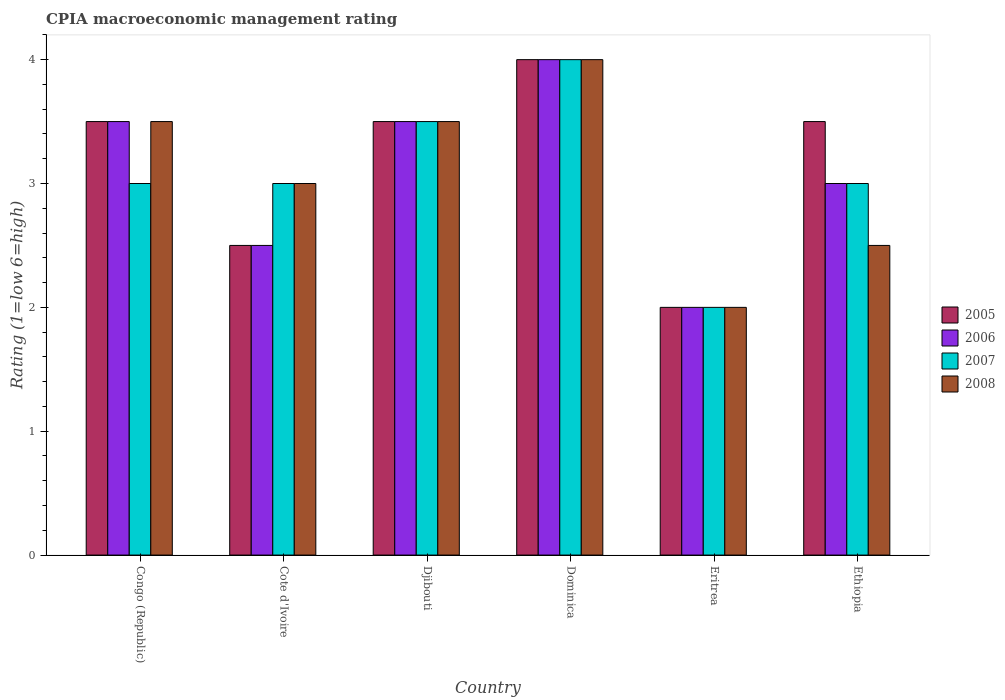How many different coloured bars are there?
Make the answer very short. 4. Are the number of bars per tick equal to the number of legend labels?
Your answer should be very brief. Yes. Are the number of bars on each tick of the X-axis equal?
Provide a short and direct response. Yes. How many bars are there on the 2nd tick from the right?
Provide a succinct answer. 4. What is the label of the 3rd group of bars from the left?
Provide a succinct answer. Djibouti. In how many cases, is the number of bars for a given country not equal to the number of legend labels?
Provide a succinct answer. 0. What is the CPIA rating in 2006 in Ethiopia?
Offer a very short reply. 3. In which country was the CPIA rating in 2006 maximum?
Give a very brief answer. Dominica. In which country was the CPIA rating in 2006 minimum?
Keep it short and to the point. Eritrea. What is the difference between the CPIA rating in 2005 in Cote d'Ivoire and the CPIA rating in 2006 in Djibouti?
Make the answer very short. -1. What is the average CPIA rating in 2007 per country?
Make the answer very short. 3.08. In how many countries, is the CPIA rating in 2005 greater than 0.6000000000000001?
Your answer should be compact. 6. What is the ratio of the CPIA rating in 2005 in Cote d'Ivoire to that in Djibouti?
Provide a succinct answer. 0.71. Is the difference between the CPIA rating in 2007 in Djibouti and Ethiopia greater than the difference between the CPIA rating in 2006 in Djibouti and Ethiopia?
Make the answer very short. No. What is the difference between the highest and the second highest CPIA rating in 2006?
Your answer should be very brief. -0.5. What is the difference between the highest and the lowest CPIA rating in 2006?
Offer a terse response. 2. Is the sum of the CPIA rating in 2006 in Djibouti and Dominica greater than the maximum CPIA rating in 2008 across all countries?
Provide a short and direct response. Yes. What does the 4th bar from the right in Djibouti represents?
Your response must be concise. 2005. Is it the case that in every country, the sum of the CPIA rating in 2007 and CPIA rating in 2008 is greater than the CPIA rating in 2005?
Give a very brief answer. Yes. How many bars are there?
Give a very brief answer. 24. How many countries are there in the graph?
Your answer should be very brief. 6. Does the graph contain grids?
Ensure brevity in your answer.  No. Where does the legend appear in the graph?
Keep it short and to the point. Center right. How many legend labels are there?
Your response must be concise. 4. What is the title of the graph?
Your response must be concise. CPIA macroeconomic management rating. What is the Rating (1=low 6=high) of 2005 in Djibouti?
Provide a succinct answer. 3.5. What is the Rating (1=low 6=high) of 2005 in Dominica?
Your response must be concise. 4. What is the Rating (1=low 6=high) of 2007 in Eritrea?
Provide a succinct answer. 2. What is the Rating (1=low 6=high) of 2008 in Eritrea?
Offer a terse response. 2. What is the Rating (1=low 6=high) of 2006 in Ethiopia?
Make the answer very short. 3. What is the Rating (1=low 6=high) in 2007 in Ethiopia?
Offer a very short reply. 3. Across all countries, what is the maximum Rating (1=low 6=high) in 2007?
Offer a very short reply. 4. Across all countries, what is the maximum Rating (1=low 6=high) of 2008?
Ensure brevity in your answer.  4. Across all countries, what is the minimum Rating (1=low 6=high) of 2005?
Offer a very short reply. 2. What is the total Rating (1=low 6=high) of 2005 in the graph?
Provide a short and direct response. 19. What is the total Rating (1=low 6=high) in 2006 in the graph?
Offer a very short reply. 18.5. What is the difference between the Rating (1=low 6=high) in 2005 in Congo (Republic) and that in Cote d'Ivoire?
Give a very brief answer. 1. What is the difference between the Rating (1=low 6=high) of 2007 in Congo (Republic) and that in Cote d'Ivoire?
Your answer should be very brief. 0. What is the difference between the Rating (1=low 6=high) in 2005 in Congo (Republic) and that in Dominica?
Provide a short and direct response. -0.5. What is the difference between the Rating (1=low 6=high) of 2008 in Congo (Republic) and that in Dominica?
Your answer should be compact. -0.5. What is the difference between the Rating (1=low 6=high) of 2006 in Congo (Republic) and that in Eritrea?
Your answer should be compact. 1.5. What is the difference between the Rating (1=low 6=high) of 2007 in Congo (Republic) and that in Eritrea?
Give a very brief answer. 1. What is the difference between the Rating (1=low 6=high) in 2005 in Congo (Republic) and that in Ethiopia?
Ensure brevity in your answer.  0. What is the difference between the Rating (1=low 6=high) in 2006 in Congo (Republic) and that in Ethiopia?
Your response must be concise. 0.5. What is the difference between the Rating (1=low 6=high) of 2007 in Congo (Republic) and that in Ethiopia?
Your answer should be compact. 0. What is the difference between the Rating (1=low 6=high) of 2006 in Cote d'Ivoire and that in Djibouti?
Keep it short and to the point. -1. What is the difference between the Rating (1=low 6=high) of 2008 in Cote d'Ivoire and that in Djibouti?
Provide a short and direct response. -0.5. What is the difference between the Rating (1=low 6=high) of 2006 in Cote d'Ivoire and that in Dominica?
Your response must be concise. -1.5. What is the difference between the Rating (1=low 6=high) of 2008 in Cote d'Ivoire and that in Dominica?
Keep it short and to the point. -1. What is the difference between the Rating (1=low 6=high) of 2006 in Cote d'Ivoire and that in Eritrea?
Your answer should be compact. 0.5. What is the difference between the Rating (1=low 6=high) of 2007 in Cote d'Ivoire and that in Eritrea?
Your answer should be compact. 1. What is the difference between the Rating (1=low 6=high) in 2008 in Cote d'Ivoire and that in Eritrea?
Provide a succinct answer. 1. What is the difference between the Rating (1=low 6=high) of 2005 in Djibouti and that in Dominica?
Provide a short and direct response. -0.5. What is the difference between the Rating (1=low 6=high) in 2006 in Djibouti and that in Dominica?
Ensure brevity in your answer.  -0.5. What is the difference between the Rating (1=low 6=high) in 2005 in Djibouti and that in Eritrea?
Provide a short and direct response. 1.5. What is the difference between the Rating (1=low 6=high) in 2006 in Djibouti and that in Eritrea?
Your response must be concise. 1.5. What is the difference between the Rating (1=low 6=high) of 2005 in Djibouti and that in Ethiopia?
Give a very brief answer. 0. What is the difference between the Rating (1=low 6=high) of 2006 in Djibouti and that in Ethiopia?
Give a very brief answer. 0.5. What is the difference between the Rating (1=low 6=high) of 2006 in Dominica and that in Eritrea?
Provide a succinct answer. 2. What is the difference between the Rating (1=low 6=high) of 2008 in Dominica and that in Eritrea?
Your answer should be very brief. 2. What is the difference between the Rating (1=low 6=high) in 2005 in Dominica and that in Ethiopia?
Your response must be concise. 0.5. What is the difference between the Rating (1=low 6=high) in 2007 in Dominica and that in Ethiopia?
Keep it short and to the point. 1. What is the difference between the Rating (1=low 6=high) of 2008 in Dominica and that in Ethiopia?
Give a very brief answer. 1.5. What is the difference between the Rating (1=low 6=high) of 2005 in Eritrea and that in Ethiopia?
Provide a short and direct response. -1.5. What is the difference between the Rating (1=low 6=high) in 2007 in Eritrea and that in Ethiopia?
Offer a very short reply. -1. What is the difference between the Rating (1=low 6=high) of 2008 in Eritrea and that in Ethiopia?
Your response must be concise. -0.5. What is the difference between the Rating (1=low 6=high) in 2005 in Congo (Republic) and the Rating (1=low 6=high) in 2006 in Cote d'Ivoire?
Your answer should be very brief. 1. What is the difference between the Rating (1=low 6=high) in 2005 in Congo (Republic) and the Rating (1=low 6=high) in 2007 in Cote d'Ivoire?
Provide a succinct answer. 0.5. What is the difference between the Rating (1=low 6=high) in 2005 in Congo (Republic) and the Rating (1=low 6=high) in 2008 in Cote d'Ivoire?
Your answer should be very brief. 0.5. What is the difference between the Rating (1=low 6=high) of 2006 in Congo (Republic) and the Rating (1=low 6=high) of 2007 in Cote d'Ivoire?
Keep it short and to the point. 0.5. What is the difference between the Rating (1=low 6=high) in 2006 in Congo (Republic) and the Rating (1=low 6=high) in 2008 in Cote d'Ivoire?
Make the answer very short. 0.5. What is the difference between the Rating (1=low 6=high) in 2005 in Congo (Republic) and the Rating (1=low 6=high) in 2008 in Djibouti?
Offer a terse response. 0. What is the difference between the Rating (1=low 6=high) in 2005 in Congo (Republic) and the Rating (1=low 6=high) in 2008 in Dominica?
Offer a very short reply. -0.5. What is the difference between the Rating (1=low 6=high) of 2006 in Congo (Republic) and the Rating (1=low 6=high) of 2007 in Dominica?
Ensure brevity in your answer.  -0.5. What is the difference between the Rating (1=low 6=high) in 2007 in Congo (Republic) and the Rating (1=low 6=high) in 2008 in Dominica?
Keep it short and to the point. -1. What is the difference between the Rating (1=low 6=high) in 2005 in Congo (Republic) and the Rating (1=low 6=high) in 2007 in Eritrea?
Give a very brief answer. 1.5. What is the difference between the Rating (1=low 6=high) in 2005 in Congo (Republic) and the Rating (1=low 6=high) in 2008 in Eritrea?
Offer a very short reply. 1.5. What is the difference between the Rating (1=low 6=high) in 2006 in Congo (Republic) and the Rating (1=low 6=high) in 2007 in Eritrea?
Make the answer very short. 1.5. What is the difference between the Rating (1=low 6=high) of 2007 in Congo (Republic) and the Rating (1=low 6=high) of 2008 in Eritrea?
Provide a succinct answer. 1. What is the difference between the Rating (1=low 6=high) in 2005 in Congo (Republic) and the Rating (1=low 6=high) in 2008 in Ethiopia?
Offer a terse response. 1. What is the difference between the Rating (1=low 6=high) in 2006 in Congo (Republic) and the Rating (1=low 6=high) in 2008 in Ethiopia?
Give a very brief answer. 1. What is the difference between the Rating (1=low 6=high) of 2005 in Cote d'Ivoire and the Rating (1=low 6=high) of 2006 in Djibouti?
Offer a very short reply. -1. What is the difference between the Rating (1=low 6=high) of 2005 in Cote d'Ivoire and the Rating (1=low 6=high) of 2007 in Djibouti?
Keep it short and to the point. -1. What is the difference between the Rating (1=low 6=high) in 2005 in Cote d'Ivoire and the Rating (1=low 6=high) in 2008 in Djibouti?
Your answer should be very brief. -1. What is the difference between the Rating (1=low 6=high) in 2006 in Cote d'Ivoire and the Rating (1=low 6=high) in 2008 in Djibouti?
Your response must be concise. -1. What is the difference between the Rating (1=low 6=high) of 2005 in Cote d'Ivoire and the Rating (1=low 6=high) of 2006 in Dominica?
Keep it short and to the point. -1.5. What is the difference between the Rating (1=low 6=high) in 2005 in Cote d'Ivoire and the Rating (1=low 6=high) in 2008 in Dominica?
Offer a very short reply. -1.5. What is the difference between the Rating (1=low 6=high) of 2006 in Cote d'Ivoire and the Rating (1=low 6=high) of 2007 in Dominica?
Your response must be concise. -1.5. What is the difference between the Rating (1=low 6=high) in 2006 in Cote d'Ivoire and the Rating (1=low 6=high) in 2008 in Dominica?
Ensure brevity in your answer.  -1.5. What is the difference between the Rating (1=low 6=high) of 2006 in Cote d'Ivoire and the Rating (1=low 6=high) of 2007 in Eritrea?
Make the answer very short. 0.5. What is the difference between the Rating (1=low 6=high) of 2006 in Cote d'Ivoire and the Rating (1=low 6=high) of 2008 in Eritrea?
Keep it short and to the point. 0.5. What is the difference between the Rating (1=low 6=high) in 2005 in Cote d'Ivoire and the Rating (1=low 6=high) in 2006 in Ethiopia?
Offer a terse response. -0.5. What is the difference between the Rating (1=low 6=high) in 2005 in Cote d'Ivoire and the Rating (1=low 6=high) in 2007 in Ethiopia?
Your response must be concise. -0.5. What is the difference between the Rating (1=low 6=high) in 2005 in Cote d'Ivoire and the Rating (1=low 6=high) in 2008 in Ethiopia?
Ensure brevity in your answer.  0. What is the difference between the Rating (1=low 6=high) in 2007 in Cote d'Ivoire and the Rating (1=low 6=high) in 2008 in Ethiopia?
Provide a succinct answer. 0.5. What is the difference between the Rating (1=low 6=high) of 2005 in Djibouti and the Rating (1=low 6=high) of 2006 in Dominica?
Give a very brief answer. -0.5. What is the difference between the Rating (1=low 6=high) of 2005 in Djibouti and the Rating (1=low 6=high) of 2008 in Dominica?
Give a very brief answer. -0.5. What is the difference between the Rating (1=low 6=high) of 2006 in Djibouti and the Rating (1=low 6=high) of 2007 in Dominica?
Your answer should be very brief. -0.5. What is the difference between the Rating (1=low 6=high) of 2006 in Djibouti and the Rating (1=low 6=high) of 2008 in Dominica?
Provide a short and direct response. -0.5. What is the difference between the Rating (1=low 6=high) in 2007 in Djibouti and the Rating (1=low 6=high) in 2008 in Dominica?
Ensure brevity in your answer.  -0.5. What is the difference between the Rating (1=low 6=high) in 2005 in Djibouti and the Rating (1=low 6=high) in 2006 in Eritrea?
Ensure brevity in your answer.  1.5. What is the difference between the Rating (1=low 6=high) in 2005 in Djibouti and the Rating (1=low 6=high) in 2007 in Eritrea?
Offer a very short reply. 1.5. What is the difference between the Rating (1=low 6=high) in 2006 in Djibouti and the Rating (1=low 6=high) in 2007 in Eritrea?
Make the answer very short. 1.5. What is the difference between the Rating (1=low 6=high) of 2006 in Djibouti and the Rating (1=low 6=high) of 2008 in Eritrea?
Keep it short and to the point. 1.5. What is the difference between the Rating (1=low 6=high) in 2005 in Djibouti and the Rating (1=low 6=high) in 2006 in Ethiopia?
Your answer should be compact. 0.5. What is the difference between the Rating (1=low 6=high) of 2005 in Djibouti and the Rating (1=low 6=high) of 2007 in Ethiopia?
Offer a terse response. 0.5. What is the difference between the Rating (1=low 6=high) of 2006 in Djibouti and the Rating (1=low 6=high) of 2008 in Ethiopia?
Provide a succinct answer. 1. What is the difference between the Rating (1=low 6=high) of 2006 in Dominica and the Rating (1=low 6=high) of 2007 in Eritrea?
Ensure brevity in your answer.  2. What is the difference between the Rating (1=low 6=high) in 2006 in Dominica and the Rating (1=low 6=high) in 2008 in Eritrea?
Your answer should be very brief. 2. What is the difference between the Rating (1=low 6=high) in 2005 in Dominica and the Rating (1=low 6=high) in 2007 in Ethiopia?
Ensure brevity in your answer.  1. What is the difference between the Rating (1=low 6=high) of 2005 in Dominica and the Rating (1=low 6=high) of 2008 in Ethiopia?
Your response must be concise. 1.5. What is the difference between the Rating (1=low 6=high) of 2006 in Dominica and the Rating (1=low 6=high) of 2007 in Ethiopia?
Your answer should be very brief. 1. What is the difference between the Rating (1=low 6=high) in 2006 in Dominica and the Rating (1=low 6=high) in 2008 in Ethiopia?
Ensure brevity in your answer.  1.5. What is the difference between the Rating (1=low 6=high) of 2007 in Dominica and the Rating (1=low 6=high) of 2008 in Ethiopia?
Offer a very short reply. 1.5. What is the difference between the Rating (1=low 6=high) in 2005 in Eritrea and the Rating (1=low 6=high) in 2006 in Ethiopia?
Give a very brief answer. -1. What is the difference between the Rating (1=low 6=high) in 2005 in Eritrea and the Rating (1=low 6=high) in 2008 in Ethiopia?
Give a very brief answer. -0.5. What is the difference between the Rating (1=low 6=high) of 2006 in Eritrea and the Rating (1=low 6=high) of 2008 in Ethiopia?
Offer a terse response. -0.5. What is the difference between the Rating (1=low 6=high) in 2007 in Eritrea and the Rating (1=low 6=high) in 2008 in Ethiopia?
Your response must be concise. -0.5. What is the average Rating (1=low 6=high) of 2005 per country?
Keep it short and to the point. 3.17. What is the average Rating (1=low 6=high) of 2006 per country?
Offer a very short reply. 3.08. What is the average Rating (1=low 6=high) of 2007 per country?
Offer a terse response. 3.08. What is the average Rating (1=low 6=high) in 2008 per country?
Your answer should be very brief. 3.08. What is the difference between the Rating (1=low 6=high) in 2005 and Rating (1=low 6=high) in 2008 in Congo (Republic)?
Offer a very short reply. 0. What is the difference between the Rating (1=low 6=high) in 2006 and Rating (1=low 6=high) in 2008 in Congo (Republic)?
Your response must be concise. 0. What is the difference between the Rating (1=low 6=high) in 2007 and Rating (1=low 6=high) in 2008 in Congo (Republic)?
Give a very brief answer. -0.5. What is the difference between the Rating (1=low 6=high) of 2005 and Rating (1=low 6=high) of 2006 in Cote d'Ivoire?
Your response must be concise. 0. What is the difference between the Rating (1=low 6=high) of 2005 and Rating (1=low 6=high) of 2007 in Cote d'Ivoire?
Your answer should be very brief. -0.5. What is the difference between the Rating (1=low 6=high) in 2006 and Rating (1=low 6=high) in 2008 in Cote d'Ivoire?
Ensure brevity in your answer.  -0.5. What is the difference between the Rating (1=low 6=high) in 2005 and Rating (1=low 6=high) in 2006 in Djibouti?
Make the answer very short. 0. What is the difference between the Rating (1=low 6=high) in 2006 and Rating (1=low 6=high) in 2007 in Djibouti?
Make the answer very short. 0. What is the difference between the Rating (1=low 6=high) in 2006 and Rating (1=low 6=high) in 2008 in Djibouti?
Provide a short and direct response. 0. What is the difference between the Rating (1=low 6=high) of 2005 and Rating (1=low 6=high) of 2006 in Dominica?
Provide a short and direct response. 0. What is the difference between the Rating (1=low 6=high) in 2005 and Rating (1=low 6=high) in 2007 in Dominica?
Give a very brief answer. 0. What is the difference between the Rating (1=low 6=high) of 2005 and Rating (1=low 6=high) of 2008 in Dominica?
Offer a terse response. 0. What is the difference between the Rating (1=low 6=high) in 2006 and Rating (1=low 6=high) in 2008 in Dominica?
Offer a very short reply. 0. What is the difference between the Rating (1=low 6=high) in 2007 and Rating (1=low 6=high) in 2008 in Dominica?
Ensure brevity in your answer.  0. What is the difference between the Rating (1=low 6=high) in 2005 and Rating (1=low 6=high) in 2007 in Ethiopia?
Your response must be concise. 0.5. What is the difference between the Rating (1=low 6=high) of 2005 and Rating (1=low 6=high) of 2008 in Ethiopia?
Offer a very short reply. 1. What is the difference between the Rating (1=low 6=high) in 2007 and Rating (1=low 6=high) in 2008 in Ethiopia?
Your answer should be compact. 0.5. What is the ratio of the Rating (1=low 6=high) of 2008 in Congo (Republic) to that in Cote d'Ivoire?
Make the answer very short. 1.17. What is the ratio of the Rating (1=low 6=high) in 2005 in Congo (Republic) to that in Djibouti?
Offer a very short reply. 1. What is the ratio of the Rating (1=low 6=high) of 2006 in Congo (Republic) to that in Djibouti?
Your response must be concise. 1. What is the ratio of the Rating (1=low 6=high) in 2008 in Congo (Republic) to that in Djibouti?
Offer a terse response. 1. What is the ratio of the Rating (1=low 6=high) of 2007 in Congo (Republic) to that in Dominica?
Your answer should be very brief. 0.75. What is the ratio of the Rating (1=low 6=high) of 2005 in Congo (Republic) to that in Eritrea?
Provide a short and direct response. 1.75. What is the ratio of the Rating (1=low 6=high) of 2006 in Congo (Republic) to that in Eritrea?
Ensure brevity in your answer.  1.75. What is the ratio of the Rating (1=low 6=high) in 2007 in Congo (Republic) to that in Eritrea?
Make the answer very short. 1.5. What is the ratio of the Rating (1=low 6=high) of 2007 in Congo (Republic) to that in Ethiopia?
Your response must be concise. 1. What is the ratio of the Rating (1=low 6=high) of 2008 in Congo (Republic) to that in Ethiopia?
Your answer should be very brief. 1.4. What is the ratio of the Rating (1=low 6=high) of 2005 in Cote d'Ivoire to that in Djibouti?
Offer a very short reply. 0.71. What is the ratio of the Rating (1=low 6=high) of 2006 in Cote d'Ivoire to that in Djibouti?
Keep it short and to the point. 0.71. What is the ratio of the Rating (1=low 6=high) in 2007 in Cote d'Ivoire to that in Djibouti?
Your answer should be compact. 0.86. What is the ratio of the Rating (1=low 6=high) in 2008 in Cote d'Ivoire to that in Djibouti?
Your response must be concise. 0.86. What is the ratio of the Rating (1=low 6=high) in 2007 in Cote d'Ivoire to that in Dominica?
Provide a short and direct response. 0.75. What is the ratio of the Rating (1=low 6=high) in 2005 in Cote d'Ivoire to that in Eritrea?
Your answer should be compact. 1.25. What is the ratio of the Rating (1=low 6=high) in 2008 in Cote d'Ivoire to that in Eritrea?
Keep it short and to the point. 1.5. What is the ratio of the Rating (1=low 6=high) of 2005 in Cote d'Ivoire to that in Ethiopia?
Make the answer very short. 0.71. What is the ratio of the Rating (1=low 6=high) of 2006 in Cote d'Ivoire to that in Ethiopia?
Offer a terse response. 0.83. What is the ratio of the Rating (1=low 6=high) of 2005 in Djibouti to that in Dominica?
Provide a succinct answer. 0.88. What is the ratio of the Rating (1=low 6=high) of 2005 in Djibouti to that in Eritrea?
Offer a terse response. 1.75. What is the ratio of the Rating (1=low 6=high) in 2007 in Djibouti to that in Eritrea?
Ensure brevity in your answer.  1.75. What is the ratio of the Rating (1=low 6=high) of 2006 in Djibouti to that in Ethiopia?
Ensure brevity in your answer.  1.17. What is the ratio of the Rating (1=low 6=high) in 2007 in Djibouti to that in Ethiopia?
Your response must be concise. 1.17. What is the ratio of the Rating (1=low 6=high) in 2007 in Dominica to that in Eritrea?
Make the answer very short. 2. What is the ratio of the Rating (1=low 6=high) in 2008 in Dominica to that in Ethiopia?
Keep it short and to the point. 1.6. What is the ratio of the Rating (1=low 6=high) in 2006 in Eritrea to that in Ethiopia?
Provide a short and direct response. 0.67. What is the difference between the highest and the second highest Rating (1=low 6=high) in 2006?
Make the answer very short. 0.5. What is the difference between the highest and the lowest Rating (1=low 6=high) in 2005?
Provide a succinct answer. 2. What is the difference between the highest and the lowest Rating (1=low 6=high) in 2008?
Your answer should be compact. 2. 